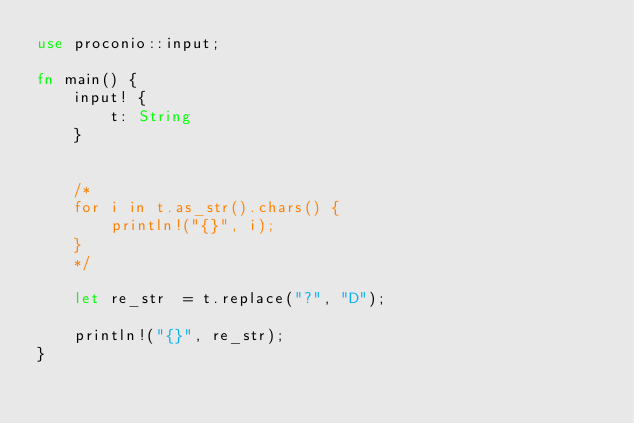<code> <loc_0><loc_0><loc_500><loc_500><_Rust_>use proconio::input;

fn main() {
    input! {
        t: String
    }


    /*
    for i in t.as_str().chars() {
        println!("{}", i);
    }
    */

    let re_str  = t.replace("?", "D");

    println!("{}", re_str);
}
</code> 